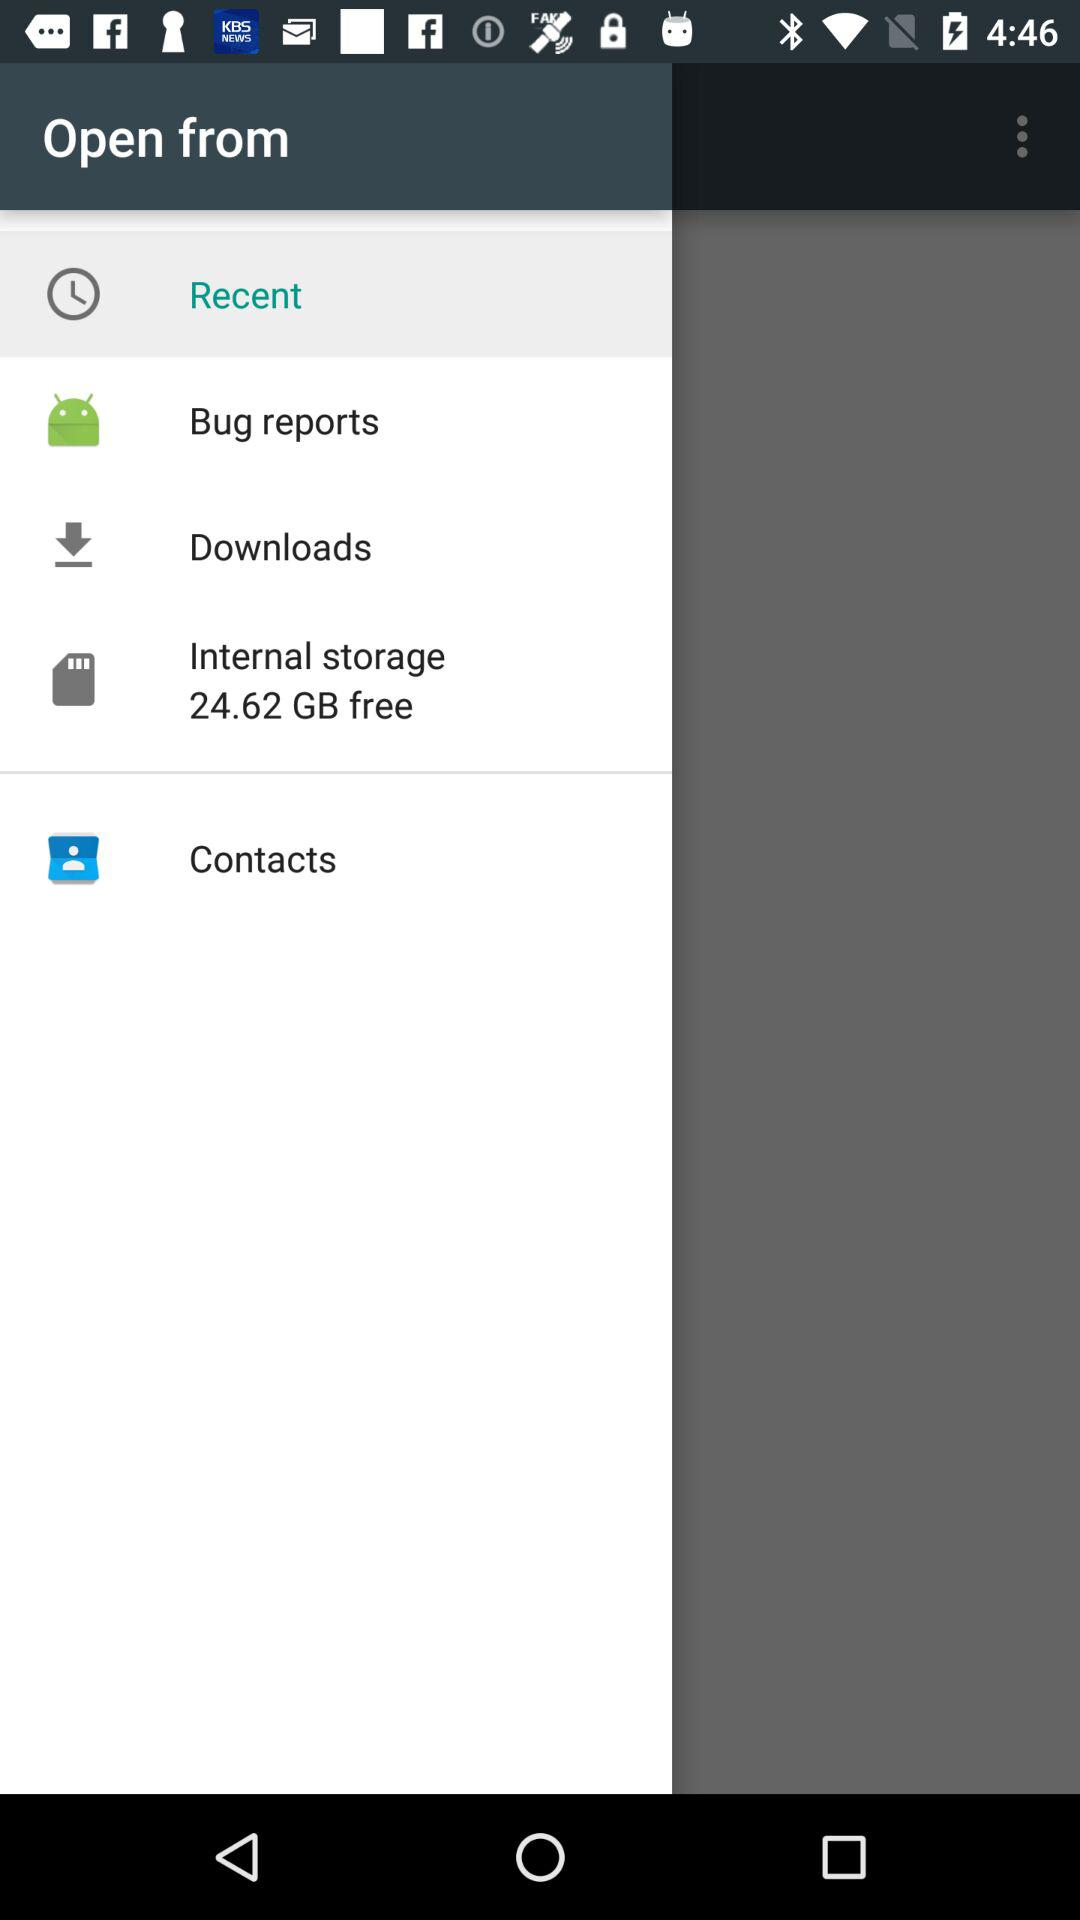How many items are in the menu other than 'Recent'?
Answer the question using a single word or phrase. 4 